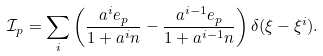Convert formula to latex. <formula><loc_0><loc_0><loc_500><loc_500>\mathcal { I } _ { p } = \sum _ { i } \left ( \frac { a ^ { i } e _ { p } } { 1 + a ^ { i } n } - \frac { a ^ { i - 1 } e _ { p } } { 1 + a ^ { i - 1 } n } \right ) \delta ( \xi - \xi ^ { i } ) .</formula> 